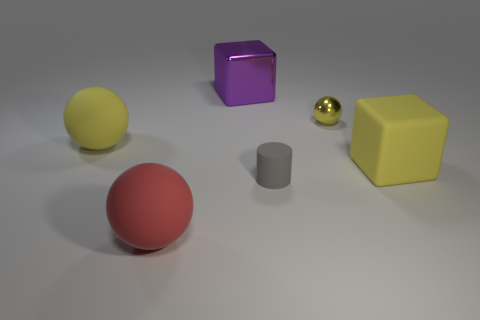Add 1 small yellow things. How many objects exist? 7 Subtract all cubes. How many objects are left? 4 Subtract 2 yellow spheres. How many objects are left? 4 Subtract all small gray rubber objects. Subtract all gray rubber objects. How many objects are left? 4 Add 5 tiny objects. How many tiny objects are left? 7 Add 1 small red balls. How many small red balls exist? 1 